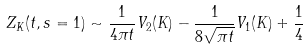<formula> <loc_0><loc_0><loc_500><loc_500>Z _ { K } ( t , s = 1 ) \sim \frac { 1 } { 4 \pi t } V _ { 2 } ( K ) - \frac { 1 } { 8 \sqrt { \pi t } } V _ { 1 } ( K ) + \frac { 1 } { 4 }</formula> 